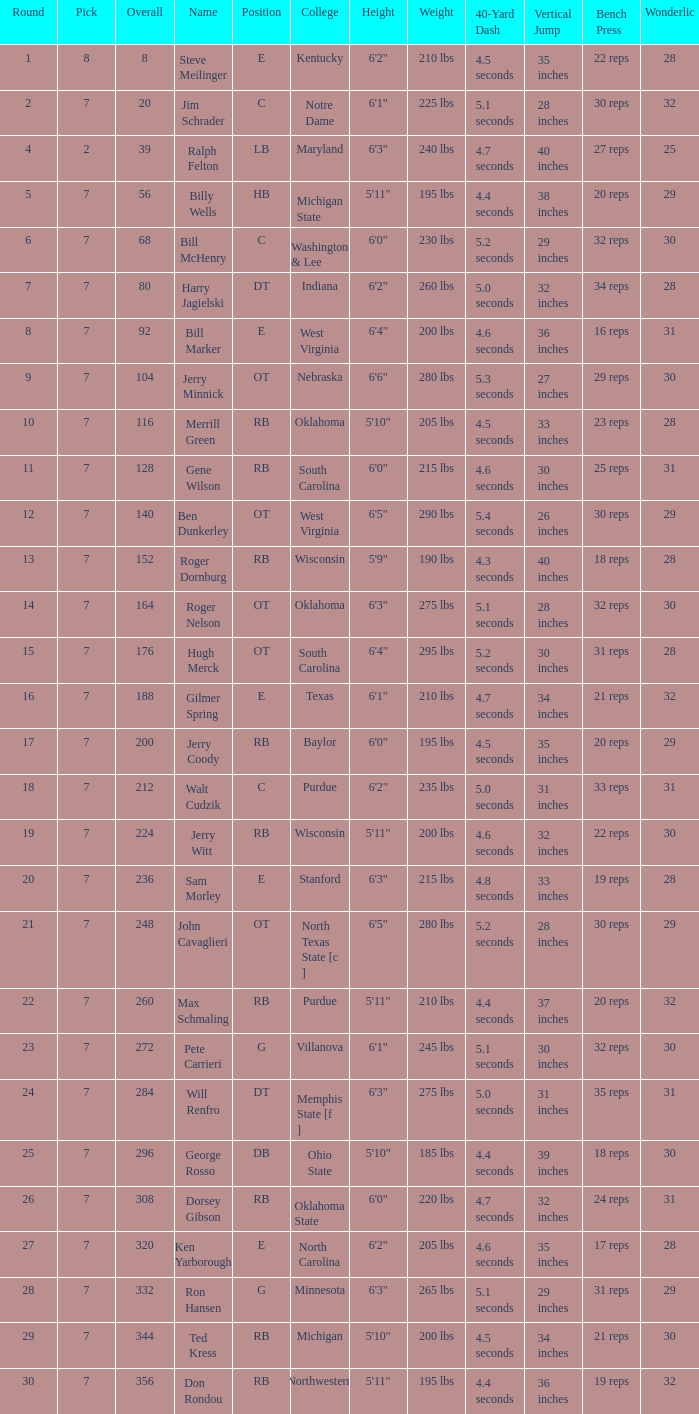What pick did George Rosso get drafted when the overall was less than 296? 0.0. 